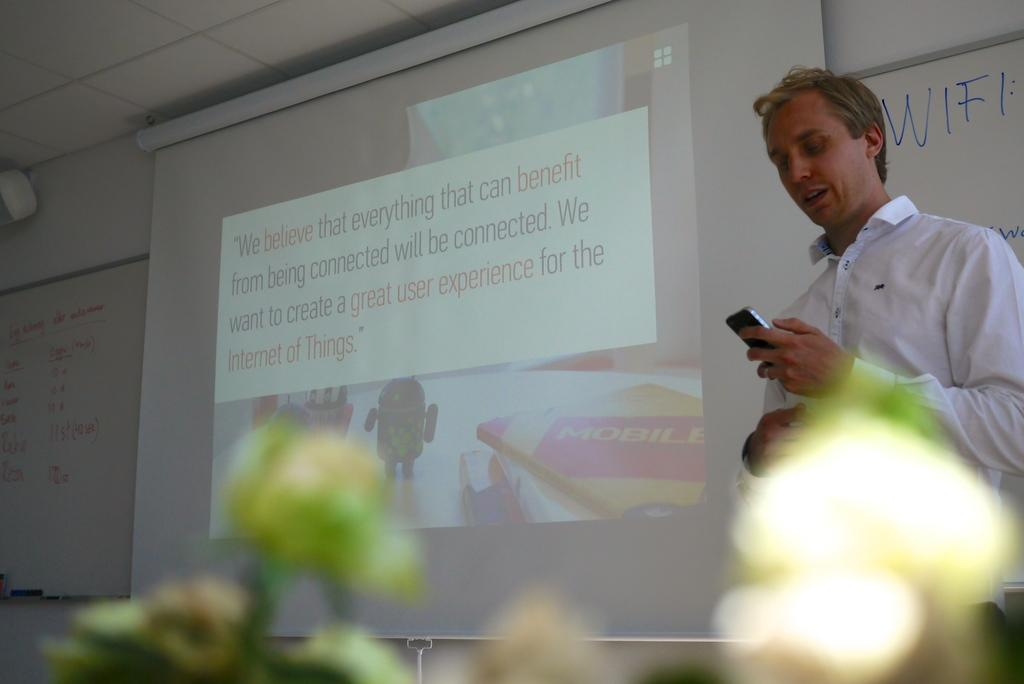What is being displayed in the image? There is a projector display in the image. What else can be seen in the room? There is a whiteboard and plants in the image. Is there anyone present in the room? Yes, there is a person standing in the image. What is the person holding in his hand? The person is holding a mobile phone in his hand. Are the friends wearing scarves in the image? There are no friends or scarves present in the image; only a person holding a mobile phone is visible. 